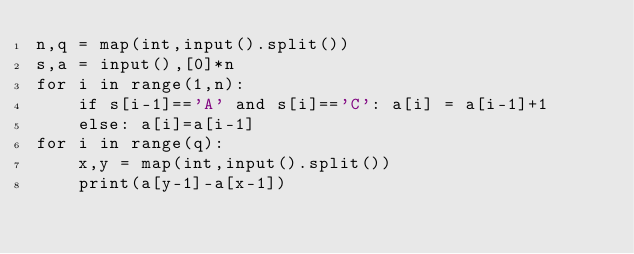Convert code to text. <code><loc_0><loc_0><loc_500><loc_500><_Python_>n,q = map(int,input().split())
s,a = input(),[0]*n
for i in range(1,n):
    if s[i-1]=='A' and s[i]=='C': a[i] = a[i-1]+1
    else: a[i]=a[i-1]
for i in range(q):
    x,y = map(int,input().split())
    print(a[y-1]-a[x-1])</code> 